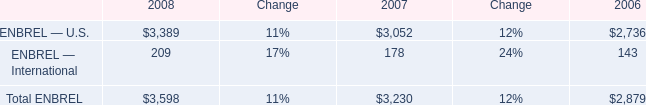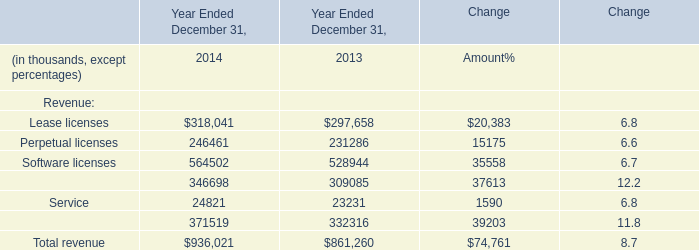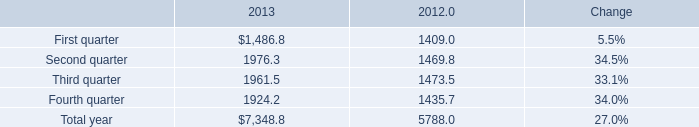what's the total amount of ENBREL — U.S. of 2007, and Perpetual licenses of Year Ended December 31, 2013 ? 
Computations: (3052.0 + 231286.0)
Answer: 234338.0. 